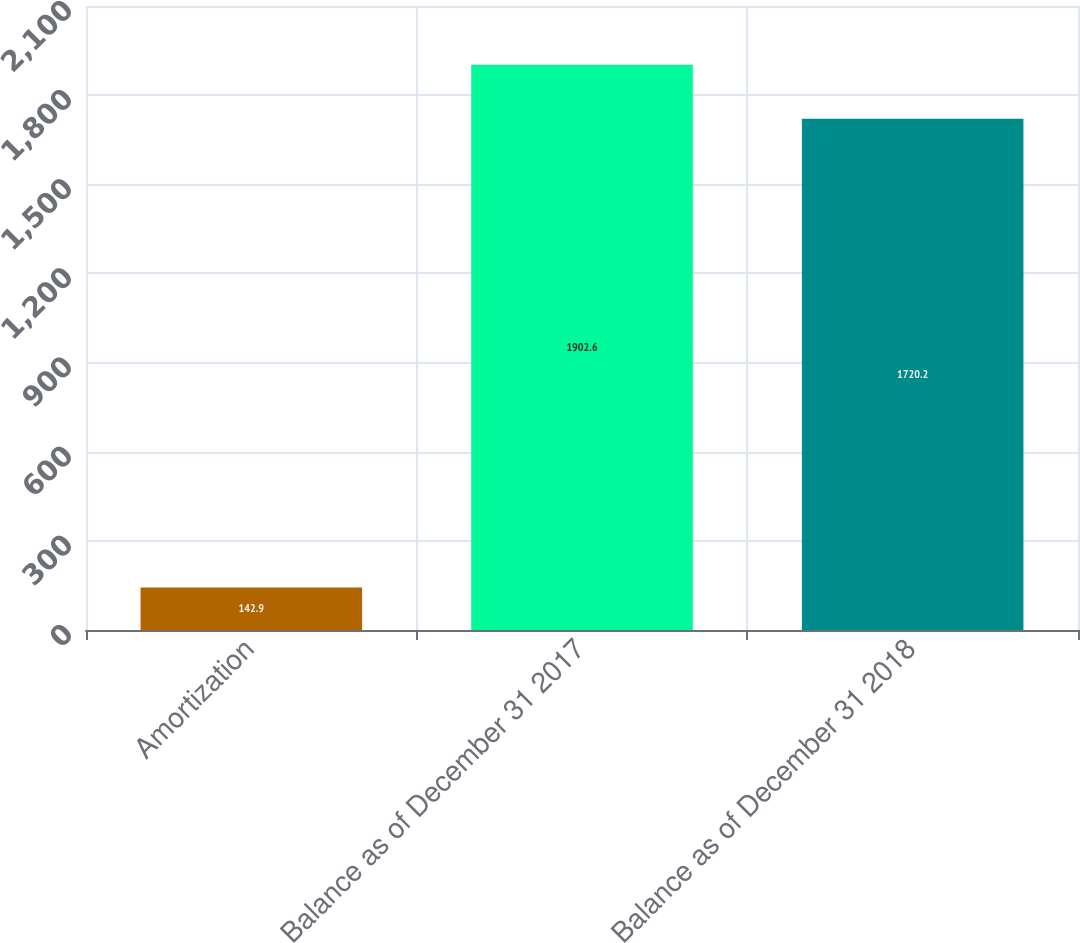<chart> <loc_0><loc_0><loc_500><loc_500><bar_chart><fcel>Amortization<fcel>Balance as of December 31 2017<fcel>Balance as of December 31 2018<nl><fcel>142.9<fcel>1902.6<fcel>1720.2<nl></chart> 